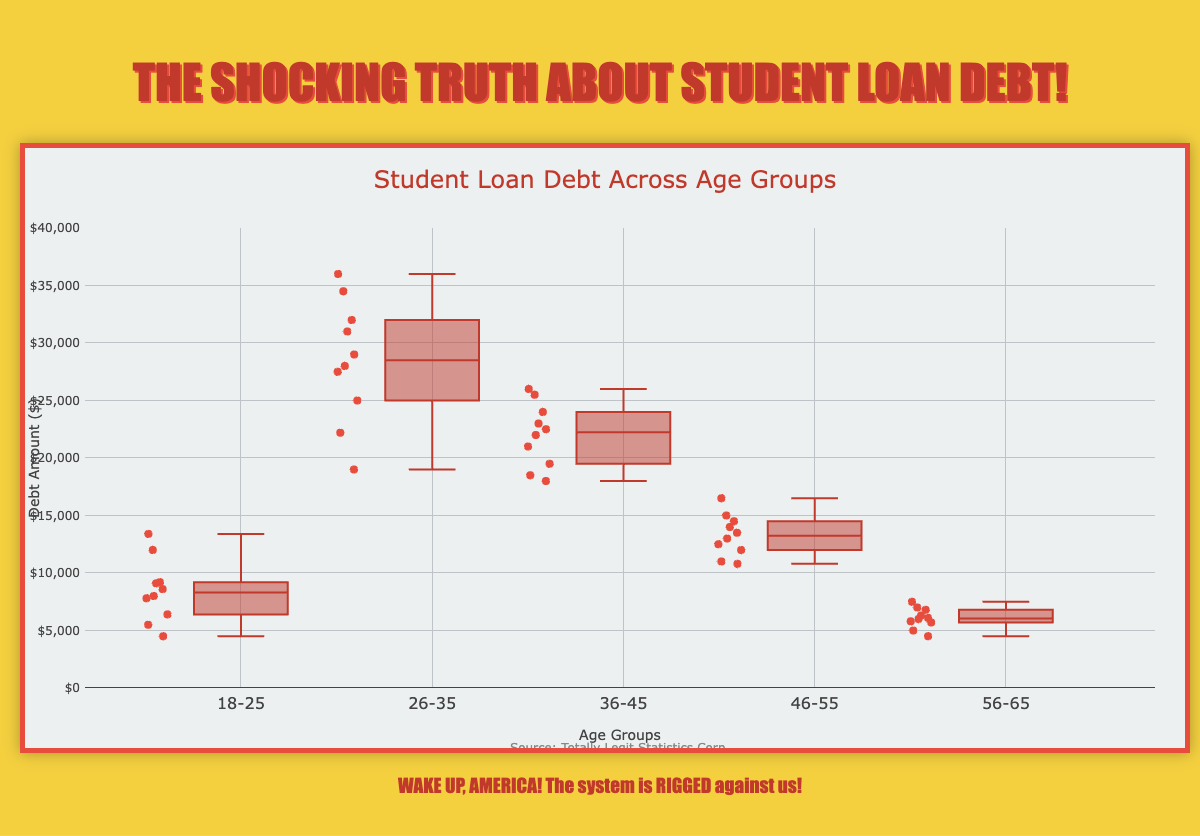What is the title of the plot? The title of the plot is displayed at the top of the chart and reads 'Student Loan Debt Across Age Groups'.
Answer: Student Loan Debt Across Age Groups What age group shows the highest median student loan debt? To find the median for each age group, look for the line inside each box plot. The 26-35 age group has the highest median line compared to the other groups.
Answer: 26-35 Which age group has the most spread (variability) in student loan debt values? The spread of the data can be observed by the length of the boxes and the whiskers. The 26-35 age group has the longest box and whiskers, indicating the highest spread.
Answer: 26-35 How many outliers are there in the 18-25 age group? In a box plot, outliers are represented by individual points outside the whiskers. By counting these points in the 18-25 group, we find there are no outliers.
Answer: 0 Which age group has the lowest maximum student loan debt value? The maximum value of each age group is represented by the topmost point of the whiskers. The 56-65 age group has the lowest maximum value.
Answer: 56-65 Compare the interquartile ranges (IQR) of the 36-45 and 46-55 age groups. Which one is larger? The IQR is the length of the box in the box plot, representing the difference between the upper and lower quartiles. The box for the 36-45 age group is larger than that for the 46-55 age group, indicating a larger IQR.
Answer: 36-45 What's the median value for the student loan debt in the 46-55 age group? The median value can be found by locating the middle line of the box in the 46-55 age group. This line is positioned at $12500.
Answer: $12500 Are there more outliers in the 26-35 age group or the 46-55 age group? Look at each age group's box plot for individual points outside the whiskers. The 26-35 age group has one outlier, while the 46-55 age group has none.
Answer: 26-35 What is the range of student loan debt for the 56-65 age group? The range is calculated by subtracting the minimum value from the maximum value. The maximum value is $7500, and the minimum value is $4500, so the range is $7500 - $4500 = $3000.
Answer: $3000 Which age group has more consistency in student loan debt values? Consistency can be observed by looking at the box plot with the smallest spread (shortest box and whiskers). The 56-65 age group shows the most consistency, with the shortest box and whiskers.
Answer: 56-65 